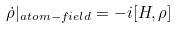<formula> <loc_0><loc_0><loc_500><loc_500>\dot { \rho } | _ { a t o m - f i e l d } = - i [ H , \rho ]</formula> 